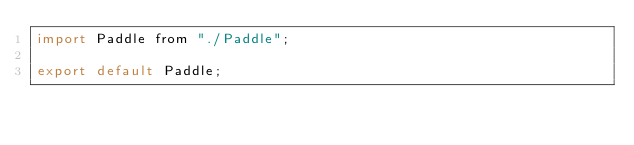<code> <loc_0><loc_0><loc_500><loc_500><_JavaScript_>import Paddle from "./Paddle";

export default Paddle;</code> 